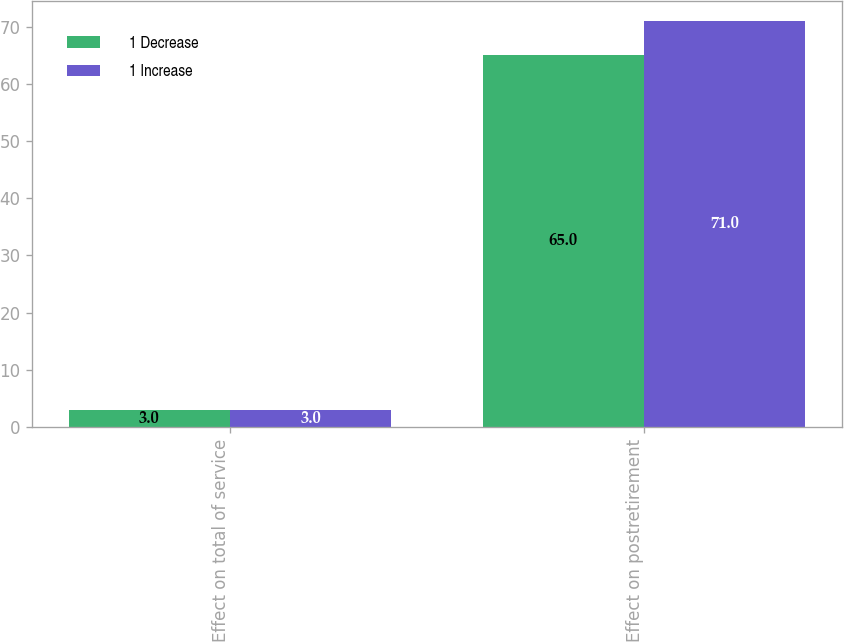Convert chart to OTSL. <chart><loc_0><loc_0><loc_500><loc_500><stacked_bar_chart><ecel><fcel>Effect on total of service<fcel>Effect on postretirement<nl><fcel>1 Decrease<fcel>3<fcel>65<nl><fcel>1 Increase<fcel>3<fcel>71<nl></chart> 